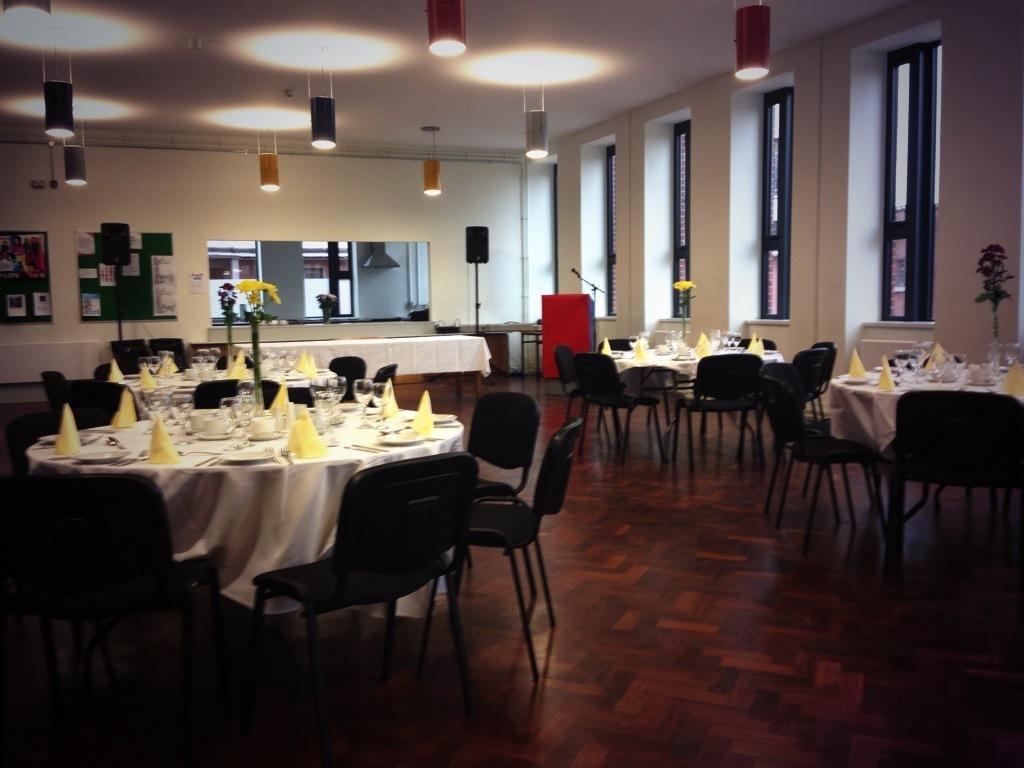Could you give a brief overview of what you see in this image? In this picture there are tables and chairs on both the sides of the image and there are windows on the right side of the image, there are lamps at the top side of the image. 